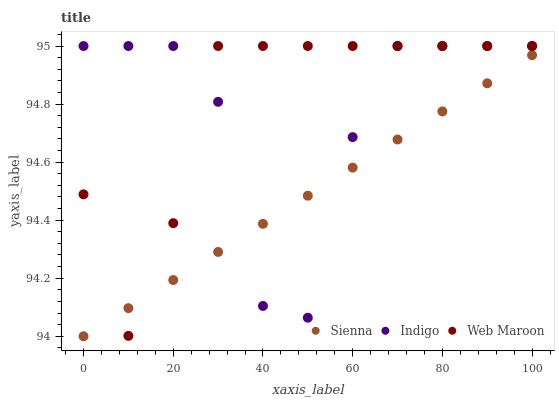Does Sienna have the minimum area under the curve?
Answer yes or no. Yes. Does Web Maroon have the maximum area under the curve?
Answer yes or no. Yes. Does Indigo have the minimum area under the curve?
Answer yes or no. No. Does Indigo have the maximum area under the curve?
Answer yes or no. No. Is Sienna the smoothest?
Answer yes or no. Yes. Is Indigo the roughest?
Answer yes or no. Yes. Is Web Maroon the smoothest?
Answer yes or no. No. Is Web Maroon the roughest?
Answer yes or no. No. Does Sienna have the lowest value?
Answer yes or no. Yes. Does Web Maroon have the lowest value?
Answer yes or no. No. Does Indigo have the highest value?
Answer yes or no. Yes. Does Sienna intersect Web Maroon?
Answer yes or no. Yes. Is Sienna less than Web Maroon?
Answer yes or no. No. Is Sienna greater than Web Maroon?
Answer yes or no. No. 